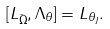Convert formula to latex. <formula><loc_0><loc_0><loc_500><loc_500>[ L _ { \bar { \Omega } } , \Lambda _ { \theta } ] = L _ { \theta _ { J } } .</formula> 